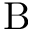<formula> <loc_0><loc_0><loc_500><loc_500>B</formula> 